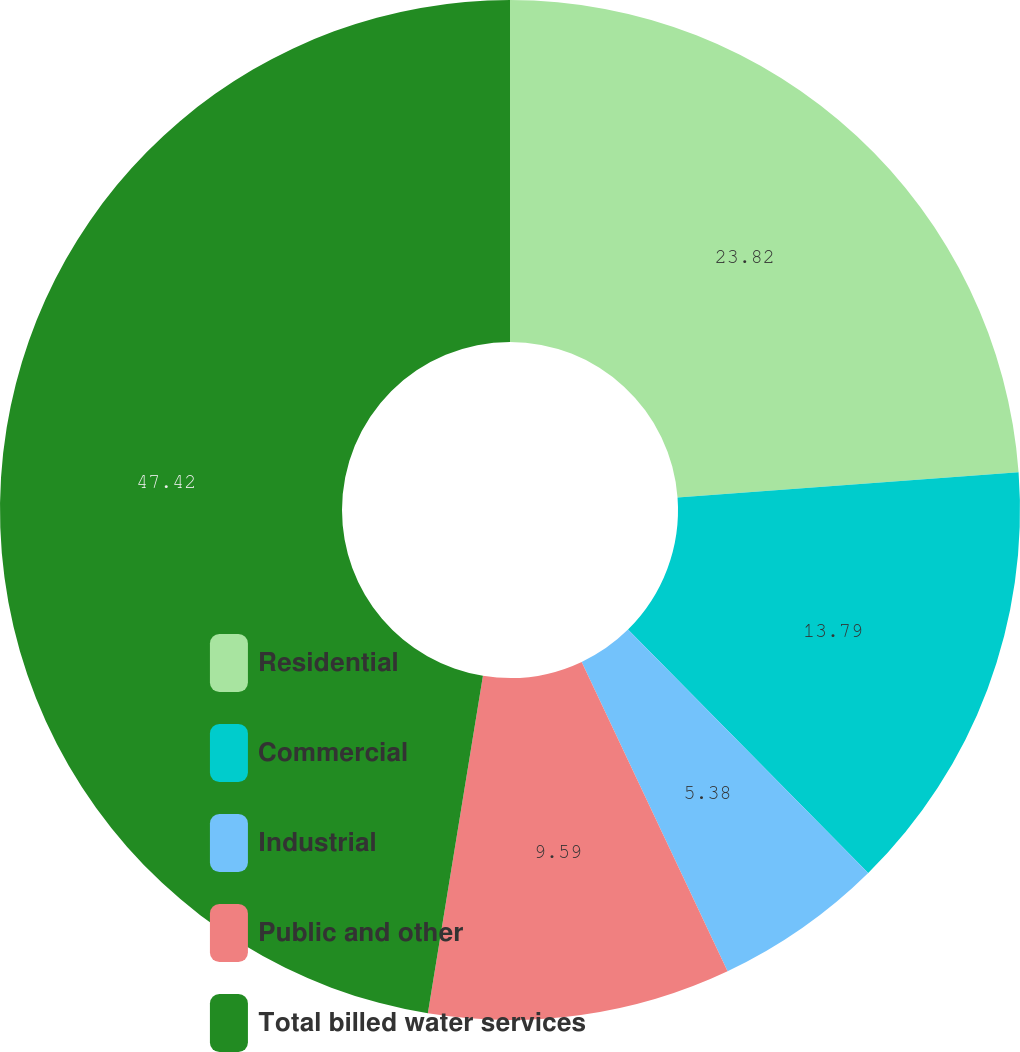Convert chart to OTSL. <chart><loc_0><loc_0><loc_500><loc_500><pie_chart><fcel>Residential<fcel>Commercial<fcel>Industrial<fcel>Public and other<fcel>Total billed water services<nl><fcel>23.82%<fcel>13.79%<fcel>5.38%<fcel>9.59%<fcel>47.43%<nl></chart> 